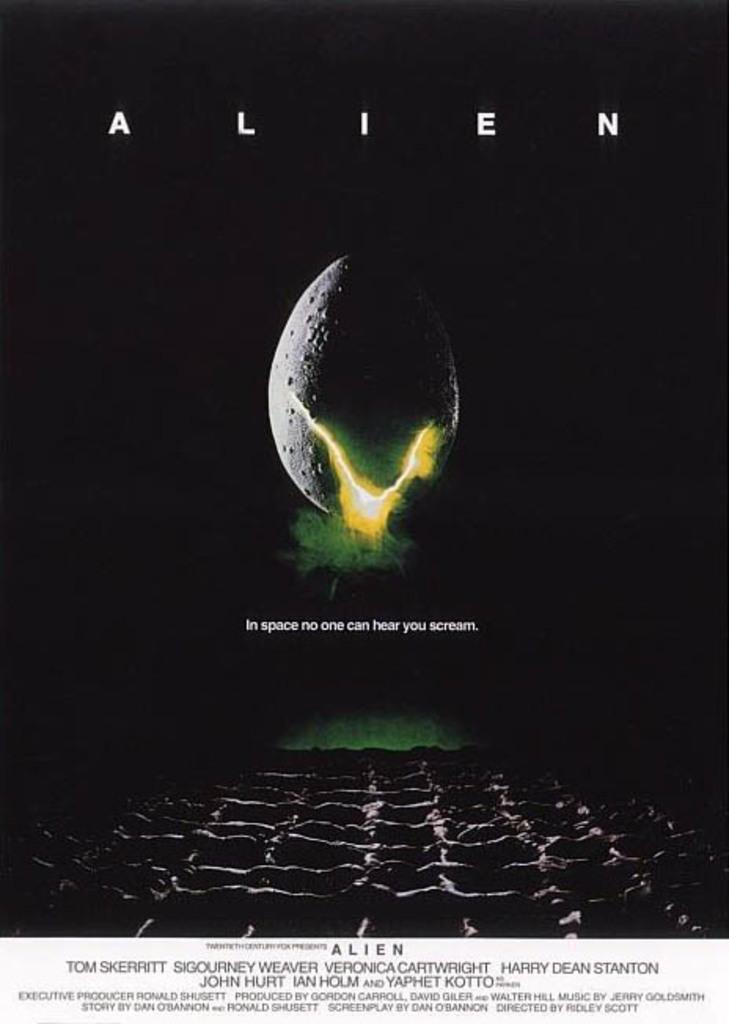<image>
Present a compact description of the photo's key features. An advertising poster for the movie Alien which has a picture of an egg splitting and the slogan In space no one can hear you scream. 